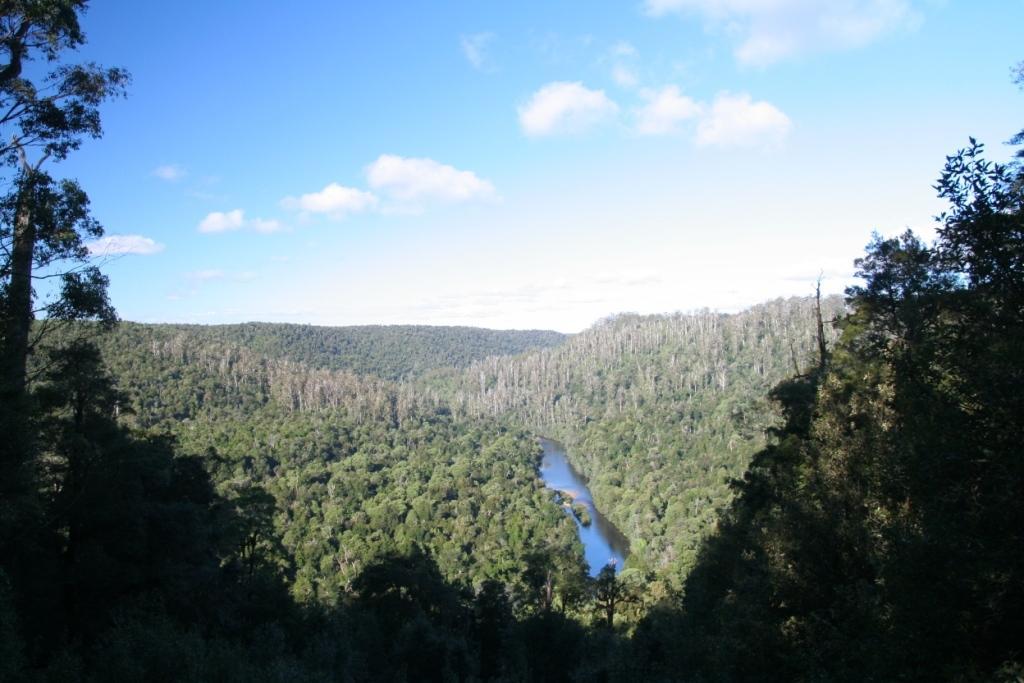In one or two sentences, can you explain what this image depicts? In this image we can see sky with clouds, trees and a river. 